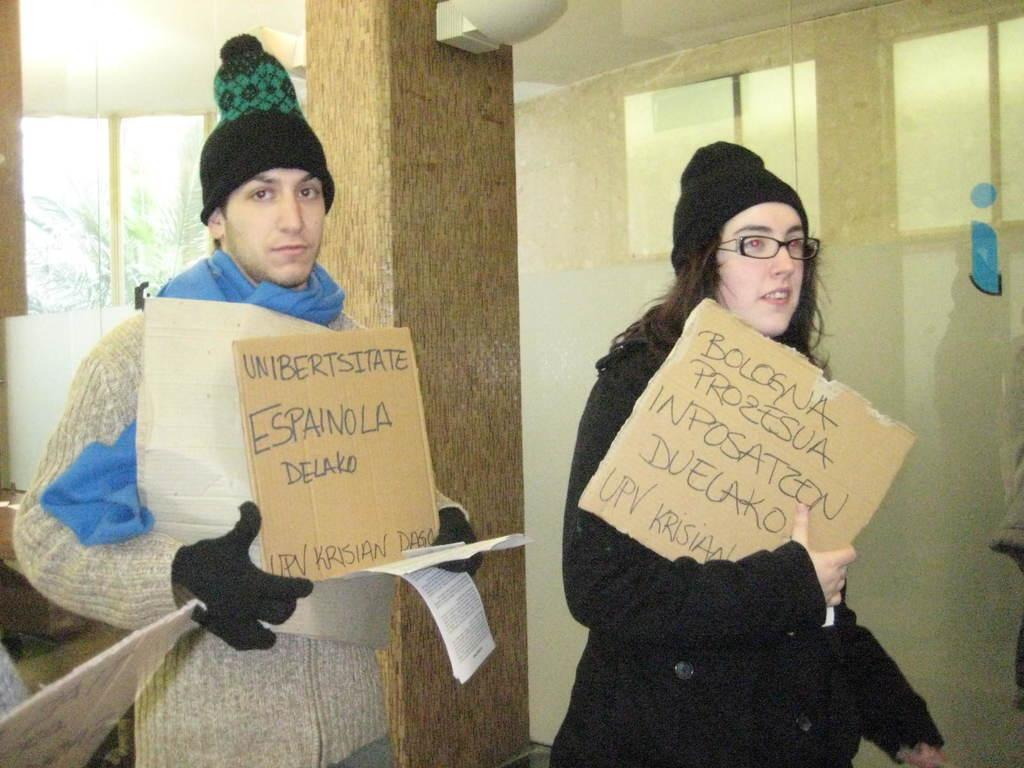Who are the two people in the center of the image? There is a man and a woman standing in the center of the image. What are the man and woman holding in the image? The man and woman are holding boards. What can be seen in the background of the image? There is a pillar, a tree, a window, and a wall in the background of the image. Reasoning: Let's think step by step by step in order to produce the conversation. We start by identifying the main subjects in the image, which are the man and woman. Then, we describe what they are doing, which is holding boards. Next, we expand the conversation to include the background elements, such as the pillar, tree, window, and wall. Each question is designed to elicit a specific detail about the image that is known from the provided facts. Absurd Question/Answer: What type of secretary is visible in the image? There is no secretary present in the image. What type of paste is being used by the man and woman in the image? There is no paste visible in the image; they are holding boards. 